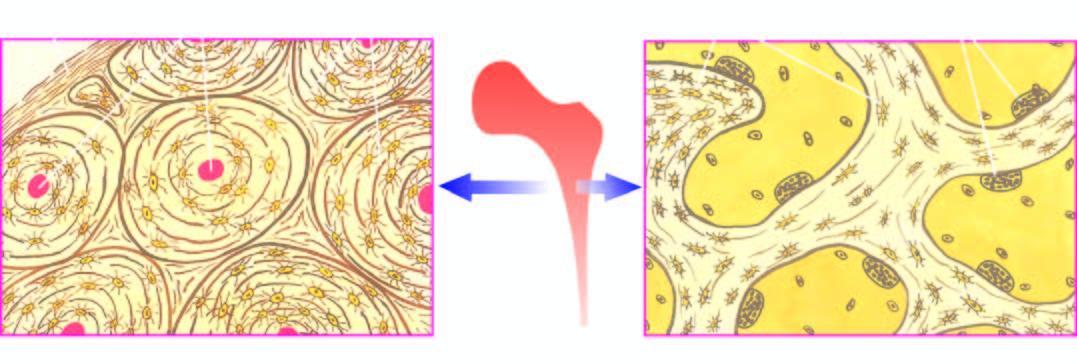does inbox show concentric lamellae along with osteocytic lacunae surrounding central blood vessels, while the trabecular bone forming the marrow space shows trabeculae with osteoclastic activity at the margins?
Answer the question using a single word or phrase. No 